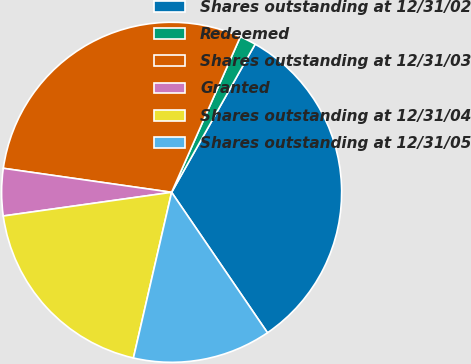Convert chart to OTSL. <chart><loc_0><loc_0><loc_500><loc_500><pie_chart><fcel>Shares outstanding at 12/31/02<fcel>Redeemed<fcel>Shares outstanding at 12/31/03<fcel>Granted<fcel>Shares outstanding at 12/31/04<fcel>Shares outstanding at 12/31/05<nl><fcel>32.3%<fcel>1.55%<fcel>29.37%<fcel>4.48%<fcel>19.17%<fcel>13.14%<nl></chart> 